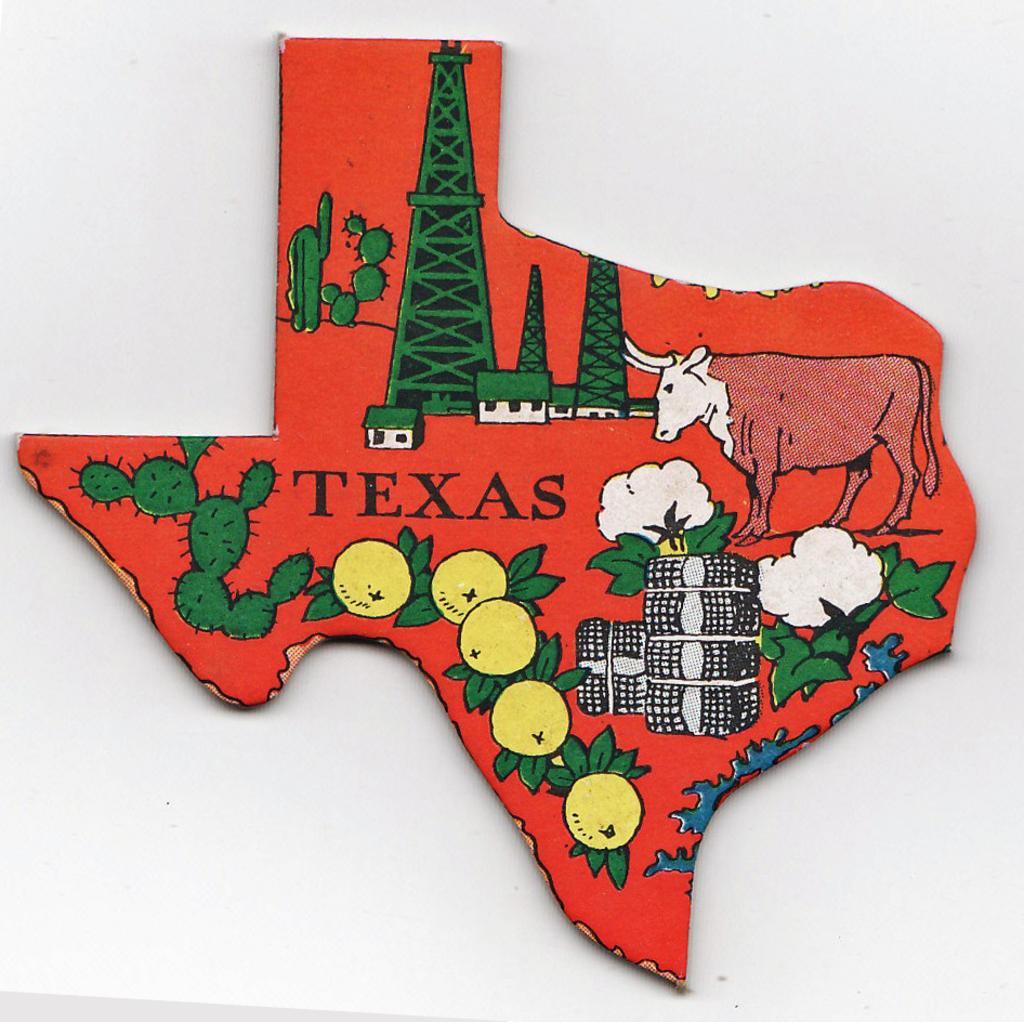What color is the board that is visible in the image? There is a red board in the image. What can be found on the red board? Something is written on the red board. What type of drawings are present in the image? There are drawings of cactus, a cow, towers, houses, boxes, and plants in the image. What is the color of the background in the image? The background of the image is white. How many girls are sitting on the lamp in the image? There are no girls or lamps present in the image. 